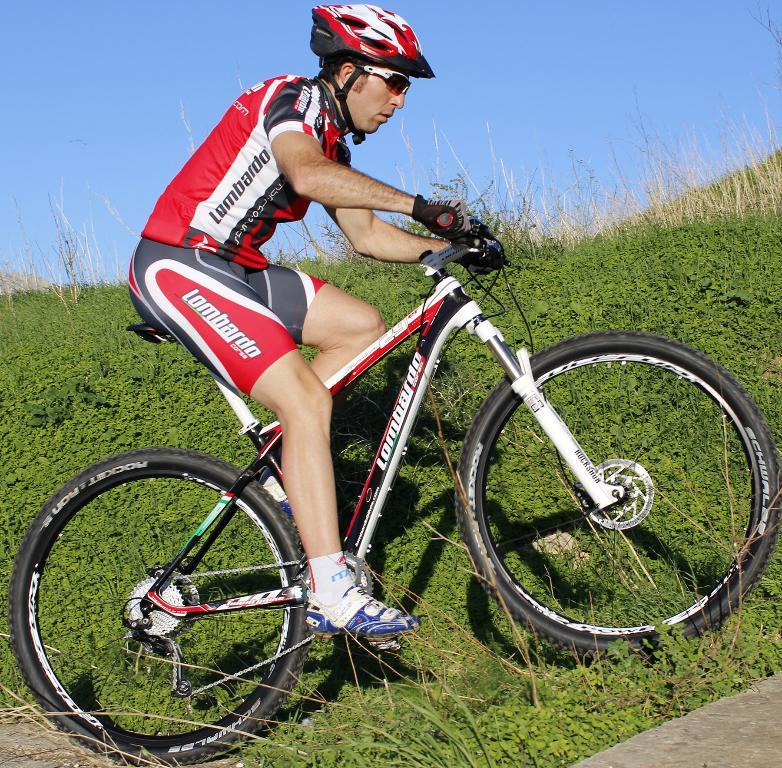What is the man in the image doing? The man is riding a bicycle in the image. Where is the man riding the bicycle? The bicycle is on the planet surface. What type of clothing is the man wearing? The man is wearing sports wear. What safety equipment is the man wearing? The man is wearing a helmet. What can be seen in the background of the image? There is a sky visible in the background of the image. What type of birthday celebration is taking place in the image? There is no indication of a birthday celebration in the image; it features a man riding a bicycle on the planet surface. What rule is being enforced in the image? There is no specific rule being enforced in the image; it simply shows a man riding a bicycle. 